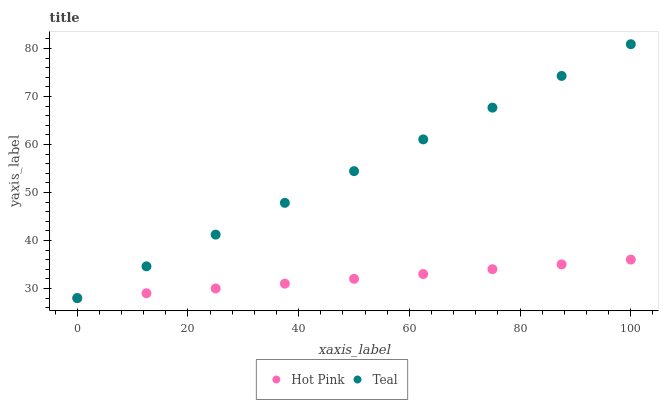Does Hot Pink have the minimum area under the curve?
Answer yes or no. Yes. Does Teal have the maximum area under the curve?
Answer yes or no. Yes. Does Teal have the minimum area under the curve?
Answer yes or no. No. Is Hot Pink the smoothest?
Answer yes or no. Yes. Is Teal the roughest?
Answer yes or no. Yes. Is Teal the smoothest?
Answer yes or no. No. Does Hot Pink have the lowest value?
Answer yes or no. Yes. Does Teal have the highest value?
Answer yes or no. Yes. Does Hot Pink intersect Teal?
Answer yes or no. Yes. Is Hot Pink less than Teal?
Answer yes or no. No. Is Hot Pink greater than Teal?
Answer yes or no. No. 